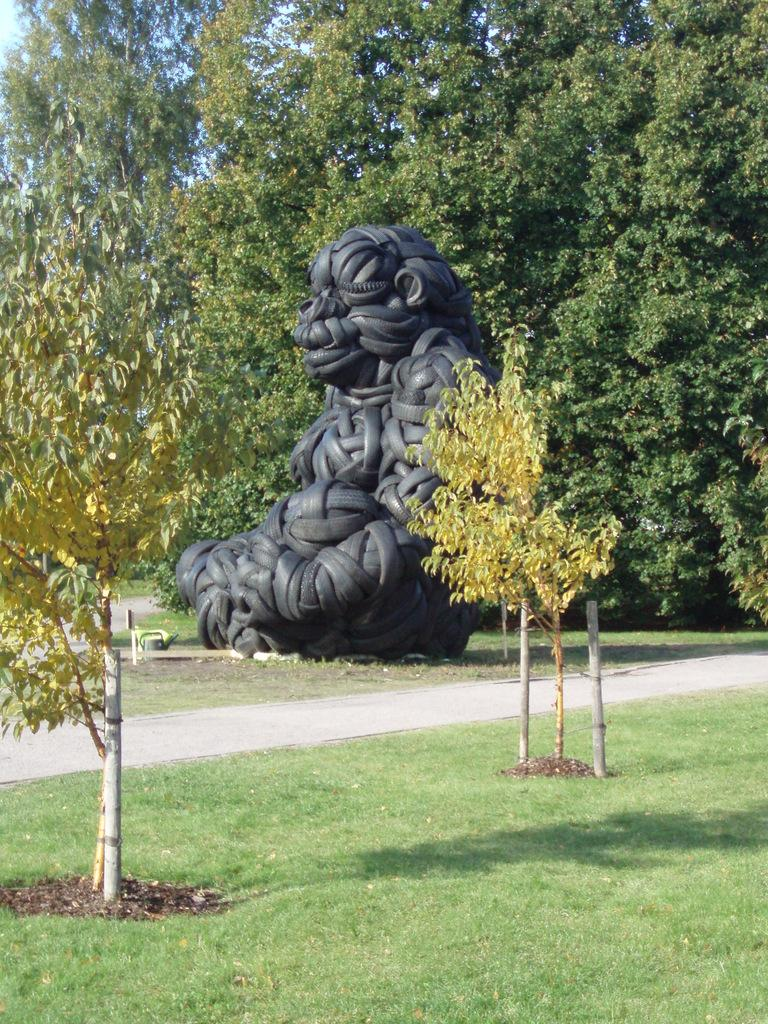What is located above the grass in the image? There is a statue above the grass in the image. What can be seen in the background of the image? There are trees in the background of the image. What book is the dad reading in the image? There is no dad or book present in the image; it only features a statue and trees in the background. 